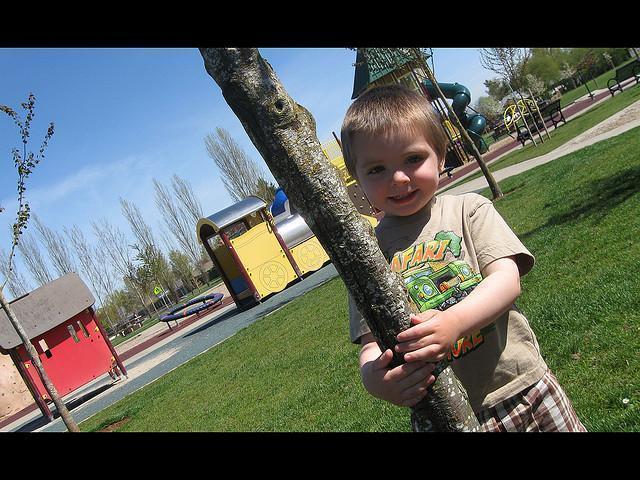At which location does the child hold the tree?
Select the correct answer and articulate reasoning with the following format: 'Answer: answer
Rationale: rationale.'
Options: Car wash, dairy barn, playground, mall. Answer: playground.
Rationale: There is a grassy area and there are toys in the background. 